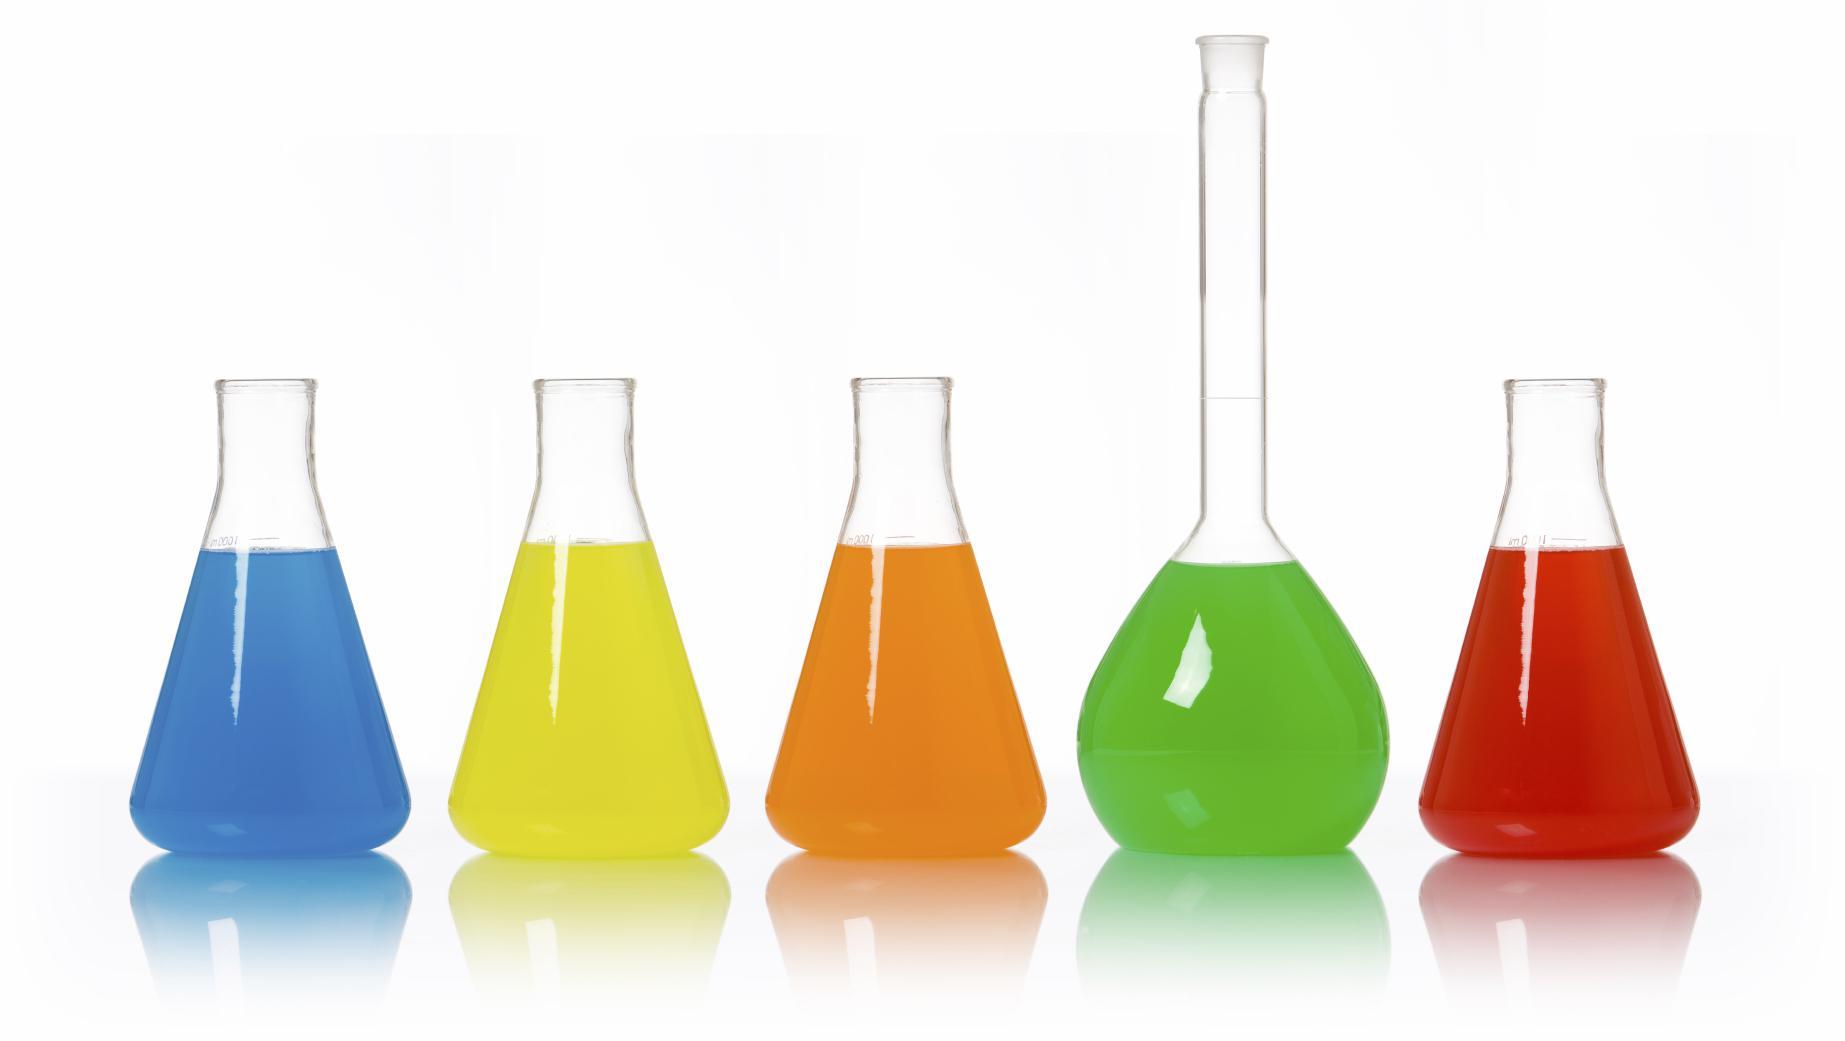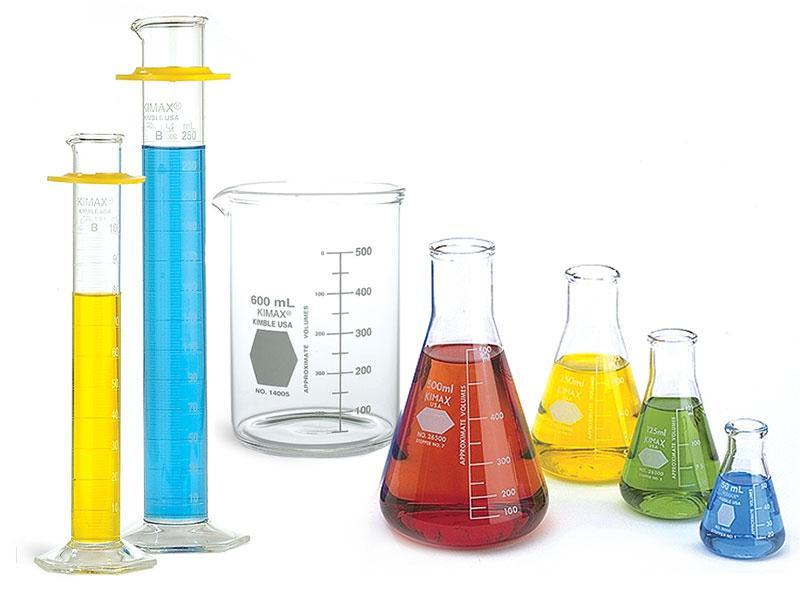The first image is the image on the left, the second image is the image on the right. Examine the images to the left and right. Is the description "One image shows exactly three containers of different colored liquids in a level row with no overlap, and one of the bottles has a round bottom and tall slender neck." accurate? Answer yes or no. No. The first image is the image on the left, the second image is the image on the right. Analyze the images presented: Is the assertion "In the image on the right, the container furthest to the left contains a blue liquid." valid? Answer yes or no. No. 